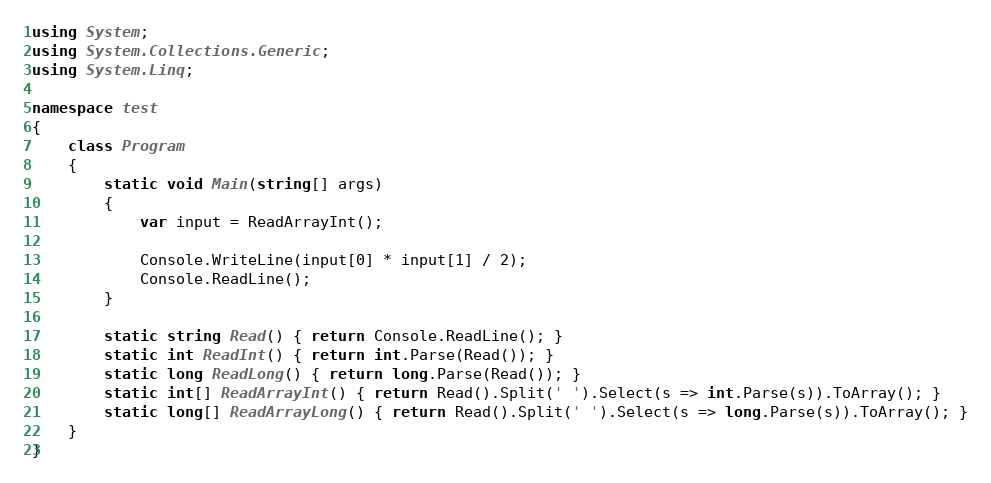Convert code to text. <code><loc_0><loc_0><loc_500><loc_500><_C#_>using System;
using System.Collections.Generic;
using System.Linq;

namespace test
{
    class Program
    {
        static void Main(string[] args)
        {
            var input = ReadArrayInt();

            Console.WriteLine(input[0] * input[1] / 2);
            Console.ReadLine();
        }

        static string Read() { return Console.ReadLine(); }
        static int ReadInt() { return int.Parse(Read()); }
        static long ReadLong() { return long.Parse(Read()); }
        static int[] ReadArrayInt() { return Read().Split(' ').Select(s => int.Parse(s)).ToArray(); }
        static long[] ReadArrayLong() { return Read().Split(' ').Select(s => long.Parse(s)).ToArray(); }
    }
}</code> 